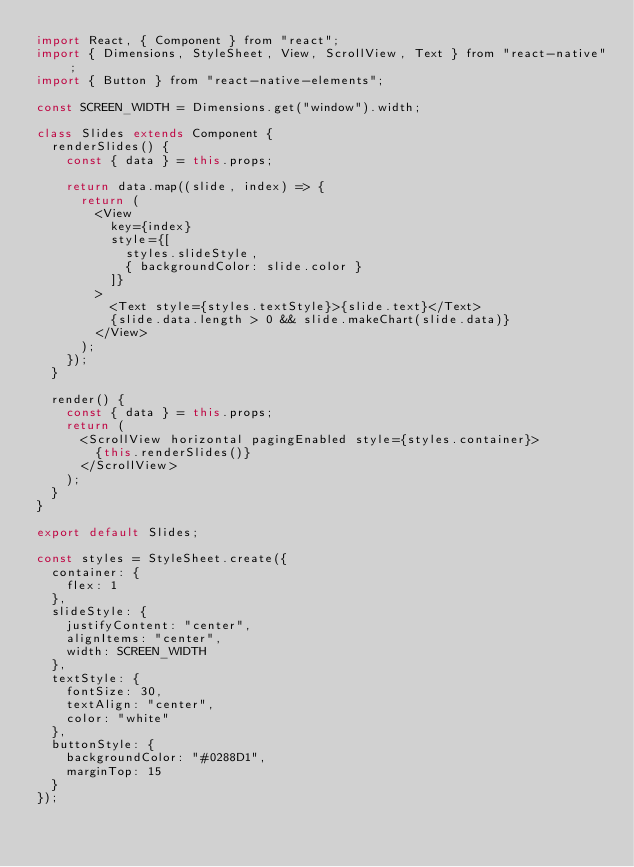<code> <loc_0><loc_0><loc_500><loc_500><_JavaScript_>import React, { Component } from "react";
import { Dimensions, StyleSheet, View, ScrollView, Text } from "react-native";
import { Button } from "react-native-elements";

const SCREEN_WIDTH = Dimensions.get("window").width;

class Slides extends Component {
	renderSlides() {
		const { data } = this.props;

		return data.map((slide, index) => {
			return (
				<View
					key={index}
					style={[
						styles.slideStyle,
						{ backgroundColor: slide.color }
					]}
				>
					<Text style={styles.textStyle}>{slide.text}</Text>
					{slide.data.length > 0 && slide.makeChart(slide.data)}
				</View>
			);
		});
	}

	render() {
		const { data } = this.props;
		return (
			<ScrollView horizontal pagingEnabled style={styles.container}>
				{this.renderSlides()}
			</ScrollView>
		);
	}
}

export default Slides;

const styles = StyleSheet.create({
	container: {
		flex: 1
	},
	slideStyle: {
		justifyContent: "center",
		alignItems: "center",
		width: SCREEN_WIDTH
	},
	textStyle: {
		fontSize: 30,
		textAlign: "center",
		color: "white"
	},
	buttonStyle: {
		backgroundColor: "#0288D1",
		marginTop: 15
	}
});
</code> 